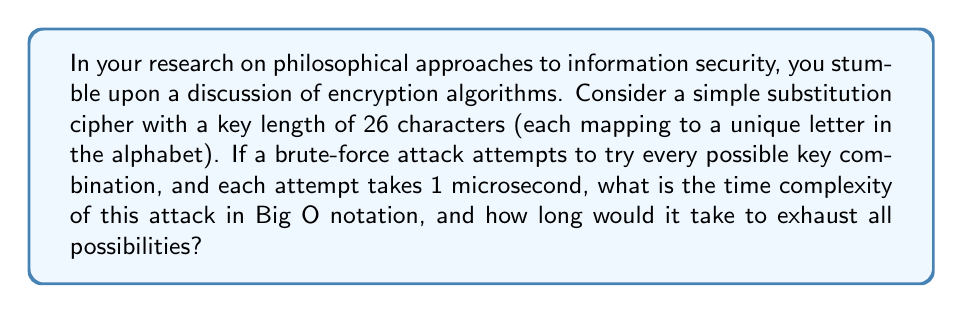Show me your answer to this math problem. To solve this problem, let's break it down step-by-step:

1. First, we need to calculate the total number of possible keys:
   - There are 26 characters in the alphabet.
   - Each character can be mapped to any of the 26 letters.
   - The number of possibilities is thus $26!$ (26 factorial).

2. Calculate $26!$:
   $26! = 1 \times 2 \times 3 \times ... \times 25 \times 26 \approx 4.03 \times 10^{26}$

3. Time complexity in Big O notation:
   - The brute-force attack needs to try all possible combinations in the worst case.
   - The number of operations is directly proportional to the number of possibilities.
   - Therefore, the time complexity is $O(26!)$ or $O(n!)$ where $n$ is the key length.

4. To calculate the actual time:
   - Each attempt takes 1 microsecond = $10^{-6}$ seconds
   - Total time = $4.03 \times 10^{26} \times 10^{-6}$ seconds
   - $= 4.03 \times 10^{20}$ seconds

5. Convert to years:
   - Seconds in a year = $365 \times 24 \times 60 \times 60 = 31,536,000$
   - Years = $\frac{4.03 \times 10^{20}}{31,536,000} \approx 1.28 \times 10^{13}$ years

Thus, the time complexity is $O(n!)$, and it would take approximately $1.28 \times 10^{13}$ years to exhaust all possibilities.
Answer: $O(n!)$, $1.28 \times 10^{13}$ years 